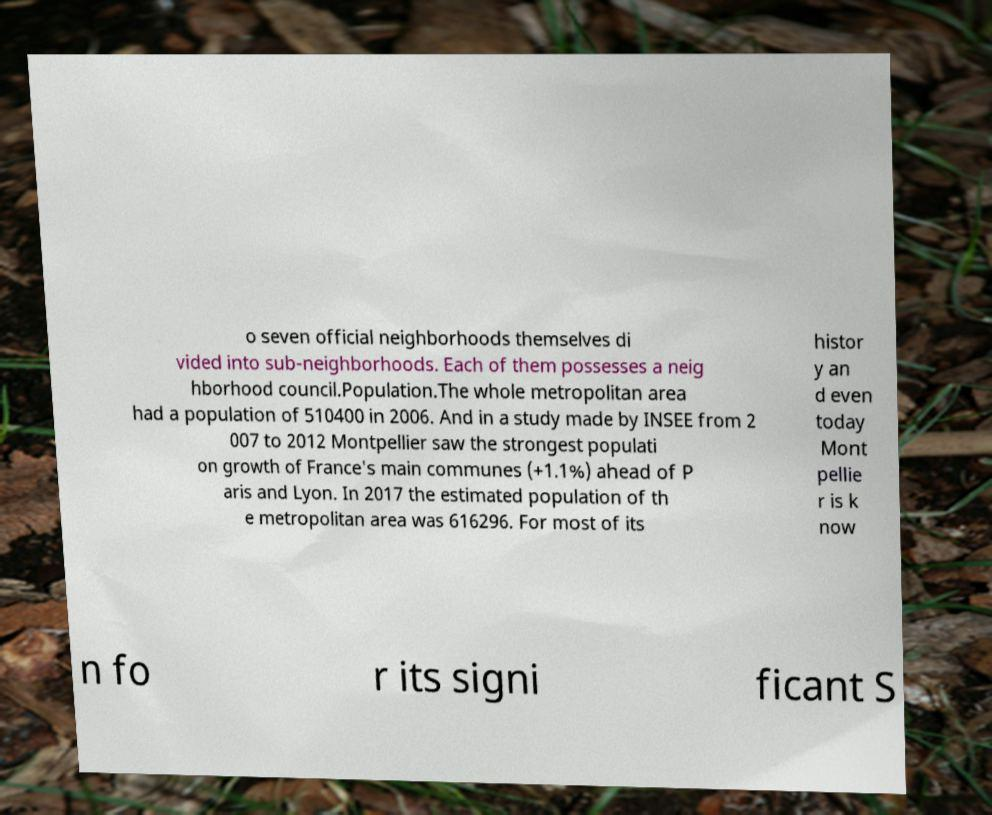I need the written content from this picture converted into text. Can you do that? o seven official neighborhoods themselves di vided into sub-neighborhoods. Each of them possesses a neig hborhood council.Population.The whole metropolitan area had a population of 510400 in 2006. And in a study made by INSEE from 2 007 to 2012 Montpellier saw the strongest populati on growth of France's main communes (+1.1%) ahead of P aris and Lyon. In 2017 the estimated population of th e metropolitan area was 616296. For most of its histor y an d even today Mont pellie r is k now n fo r its signi ficant S 